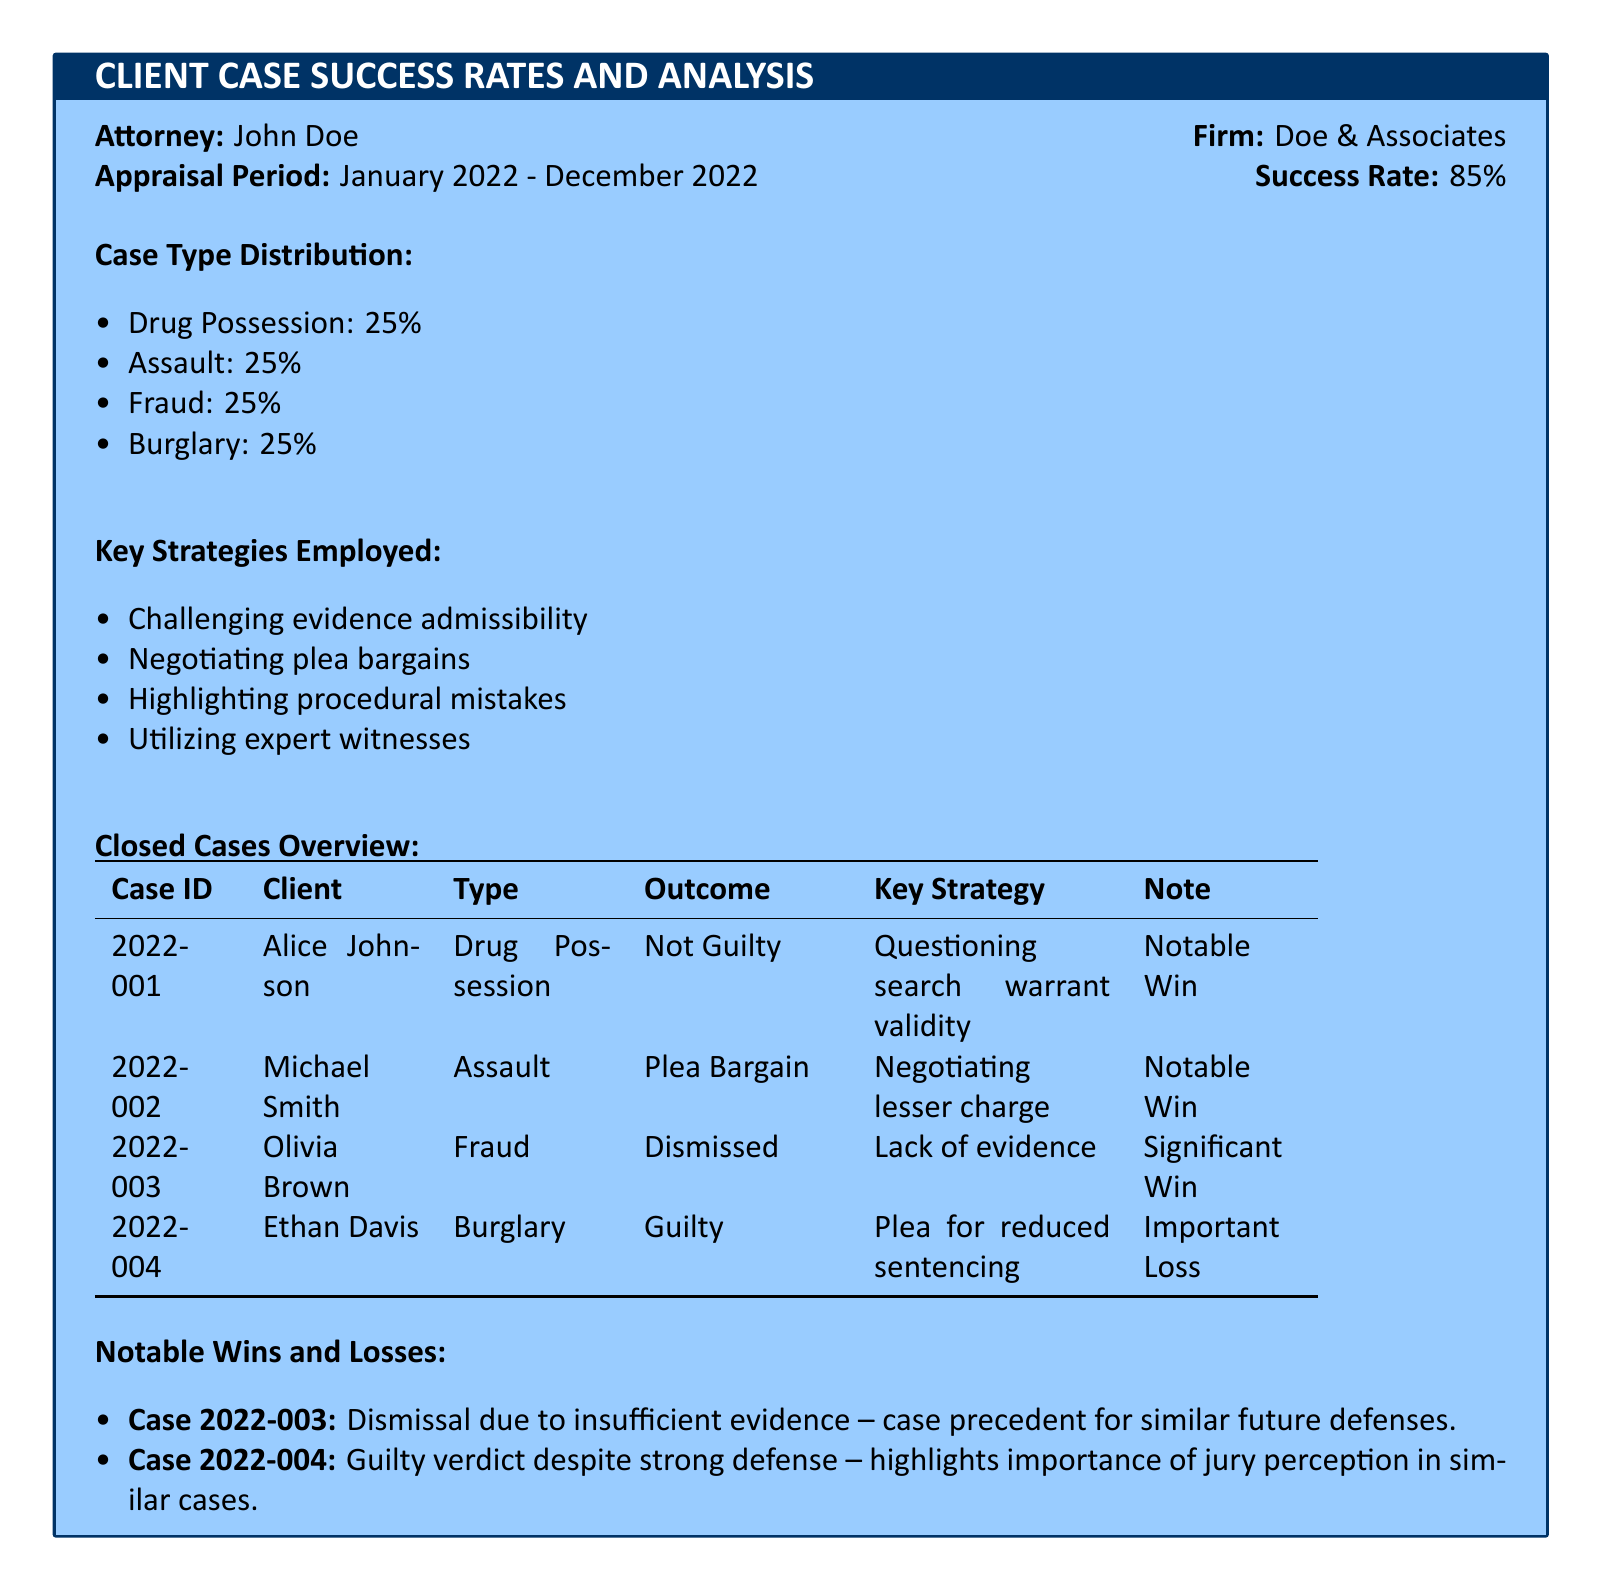What is the attorney's name? The attorney's name is specified in the document under the attorney section.
Answer: John Doe What is the appraisal period? The appraisal period is detailed in the document, indicating the time frame for the statistics provided.
Answer: January 2022 - December 2022 What is the success rate mentioned? The success rate is explicitly stated in the document, representing the percentage of successful cases.
Answer: 85% What type of case has the highest distribution? Case type distributions show equal percentages; therefore, this is based on the provided values in the document.
Answer: All types (Drug Possession, Assault, Fraud, Burglary) What key strategy was employed in case 2022-003? The key strategy for each case is itemized in the overview, specifying the approach taken.
Answer: Lack of evidence How many cases resulted in a guilty outcome? By summing the outcomes listed in the table, we can determine the count of guilty outcomes.
Answer: 1 Which case resulted in a dismissal? The specific outcome of each case is listed, relating to the notable win or loss status.
Answer: Case 2022-003 What is the notable win for case 2022-001? The document notes key strategies and their results; the notable aspect of the case is outlined.
Answer: Notable Win What percentage of cases were related to fraud? Case type distributions are provided as percentages; the document specifies the breakdown clearly.
Answer: 25% 